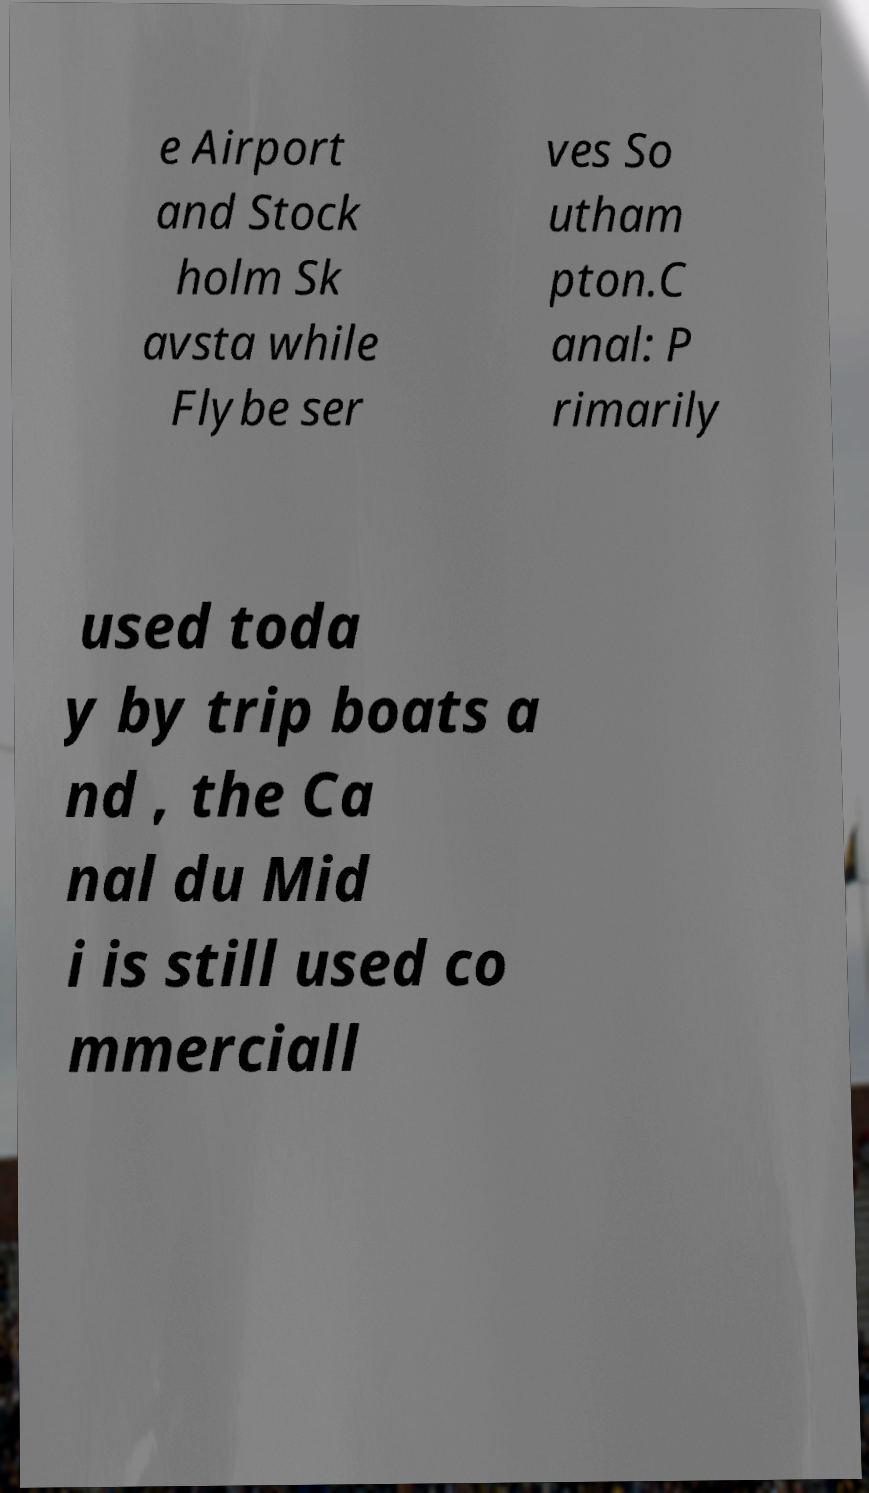I need the written content from this picture converted into text. Can you do that? e Airport and Stock holm Sk avsta while Flybe ser ves So utham pton.C anal: P rimarily used toda y by trip boats a nd , the Ca nal du Mid i is still used co mmerciall 